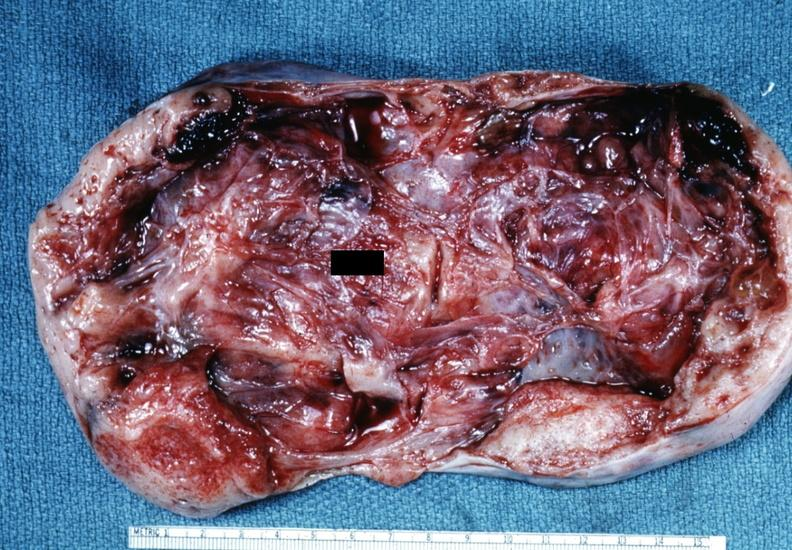s metastatic carcinoma lung present?
Answer the question using a single word or phrase. No 